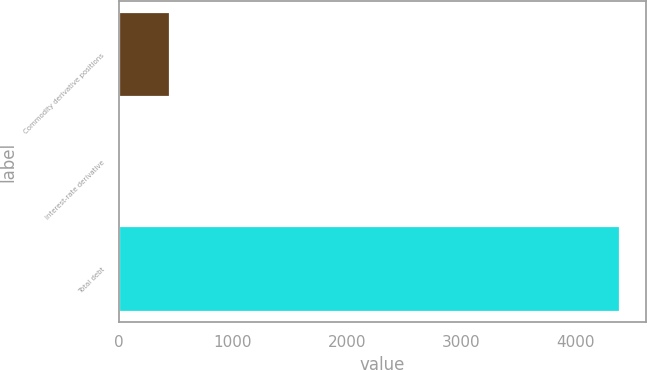<chart> <loc_0><loc_0><loc_500><loc_500><bar_chart><fcel>Commodity derivative positions<fcel>Interest-rate derivative<fcel>Total debt<nl><fcel>445.1<fcel>6<fcel>4397<nl></chart> 